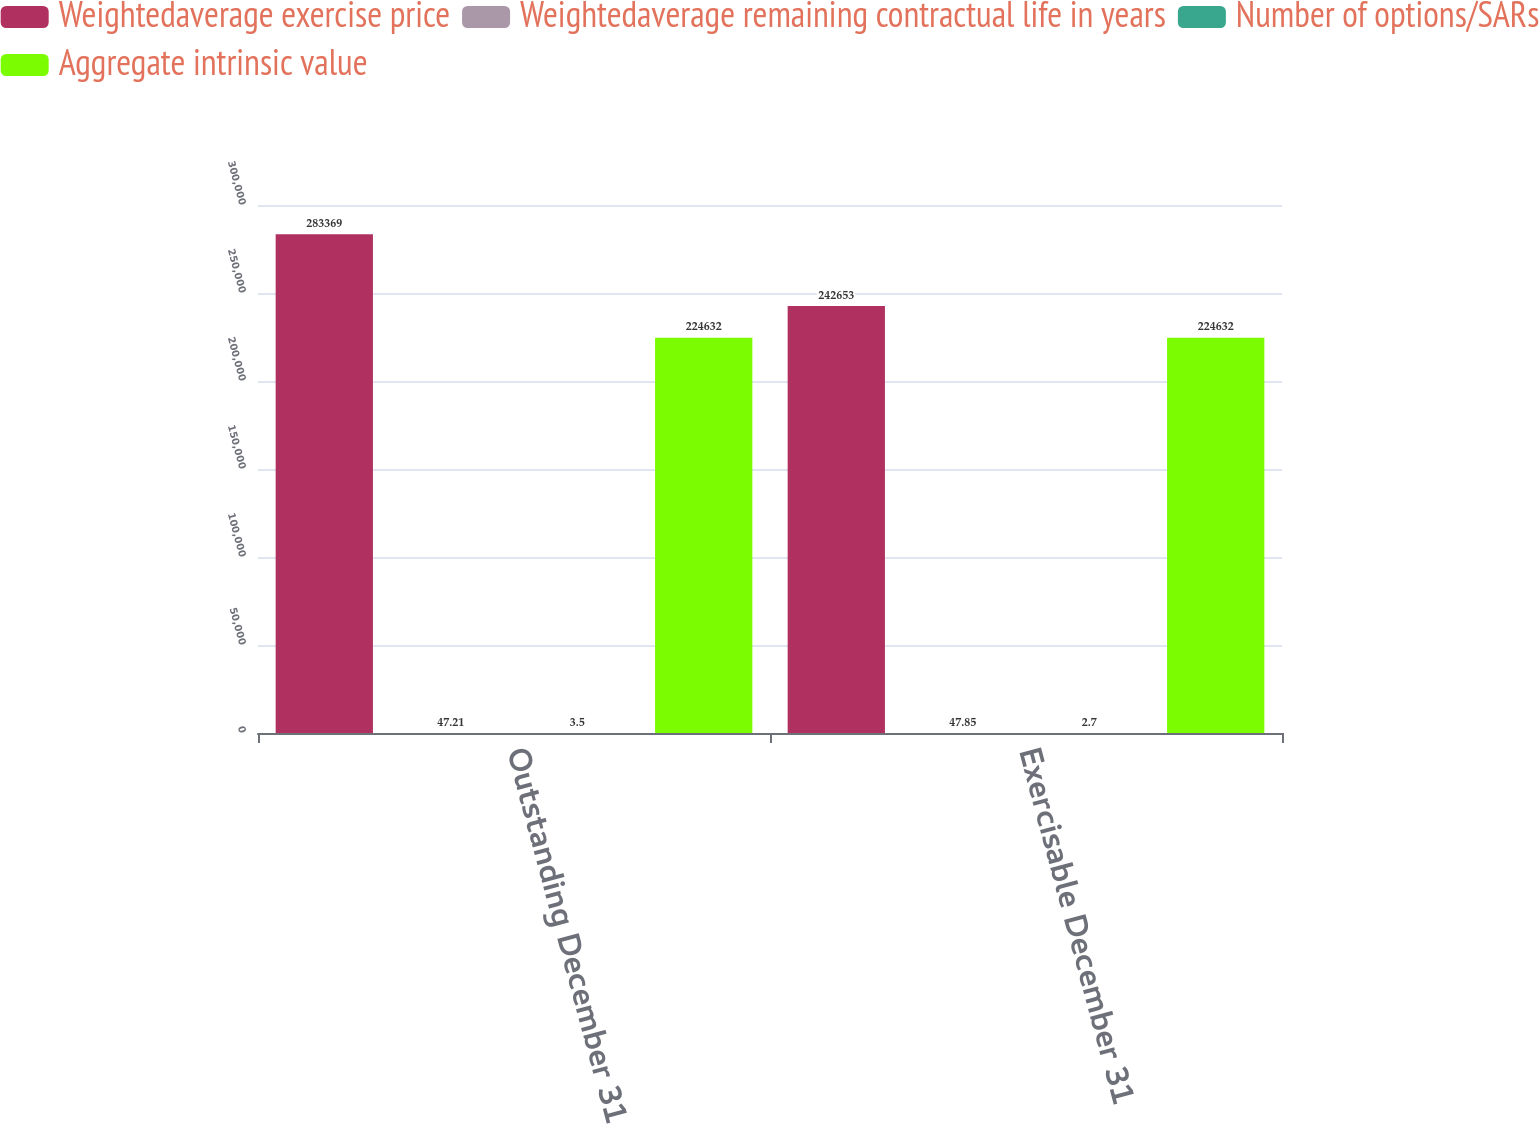Convert chart to OTSL. <chart><loc_0><loc_0><loc_500><loc_500><stacked_bar_chart><ecel><fcel>Outstanding December 31<fcel>Exercisable December 31<nl><fcel>Weightedaverage exercise price<fcel>283369<fcel>242653<nl><fcel>Weightedaverage remaining contractual life in years<fcel>47.21<fcel>47.85<nl><fcel>Number of options/SARs<fcel>3.5<fcel>2.7<nl><fcel>Aggregate intrinsic value<fcel>224632<fcel>224632<nl></chart> 